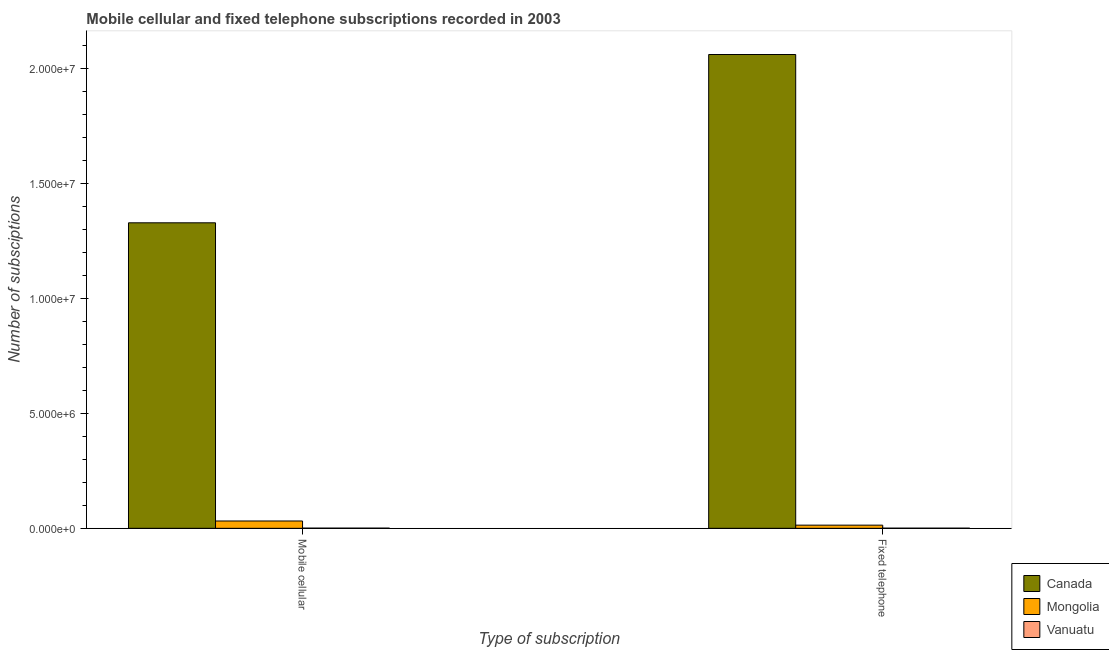Are the number of bars per tick equal to the number of legend labels?
Keep it short and to the point. Yes. How many bars are there on the 2nd tick from the left?
Make the answer very short. 3. How many bars are there on the 1st tick from the right?
Ensure brevity in your answer.  3. What is the label of the 2nd group of bars from the left?
Your answer should be very brief. Fixed telephone. What is the number of fixed telephone subscriptions in Mongolia?
Make the answer very short. 1.38e+05. Across all countries, what is the maximum number of fixed telephone subscriptions?
Provide a succinct answer. 2.06e+07. Across all countries, what is the minimum number of mobile cellular subscriptions?
Ensure brevity in your answer.  7800. In which country was the number of fixed telephone subscriptions minimum?
Provide a short and direct response. Vanuatu. What is the total number of fixed telephone subscriptions in the graph?
Your response must be concise. 2.08e+07. What is the difference between the number of fixed telephone subscriptions in Vanuatu and that in Mongolia?
Your answer should be compact. -1.32e+05. What is the difference between the number of mobile cellular subscriptions in Canada and the number of fixed telephone subscriptions in Mongolia?
Provide a short and direct response. 1.32e+07. What is the average number of mobile cellular subscriptions per country?
Your answer should be compact. 4.54e+06. What is the difference between the number of mobile cellular subscriptions and number of fixed telephone subscriptions in Mongolia?
Offer a terse response. 1.81e+05. In how many countries, is the number of fixed telephone subscriptions greater than 10000000 ?
Provide a succinct answer. 1. What is the ratio of the number of fixed telephone subscriptions in Canada to that in Mongolia?
Give a very brief answer. 149.21. Is the number of mobile cellular subscriptions in Canada less than that in Mongolia?
Your response must be concise. No. What does the 1st bar from the right in Mobile cellular represents?
Your response must be concise. Vanuatu. How many bars are there?
Keep it short and to the point. 6. How many countries are there in the graph?
Give a very brief answer. 3. What is the difference between two consecutive major ticks on the Y-axis?
Your answer should be compact. 5.00e+06. Are the values on the major ticks of Y-axis written in scientific E-notation?
Give a very brief answer. Yes. How many legend labels are there?
Keep it short and to the point. 3. How are the legend labels stacked?
Make the answer very short. Vertical. What is the title of the graph?
Give a very brief answer. Mobile cellular and fixed telephone subscriptions recorded in 2003. Does "Portugal" appear as one of the legend labels in the graph?
Offer a very short reply. No. What is the label or title of the X-axis?
Your answer should be very brief. Type of subscription. What is the label or title of the Y-axis?
Offer a terse response. Number of subsciptions. What is the Number of subsciptions of Canada in Mobile cellular?
Ensure brevity in your answer.  1.33e+07. What is the Number of subsciptions in Mongolia in Mobile cellular?
Offer a terse response. 3.19e+05. What is the Number of subsciptions of Vanuatu in Mobile cellular?
Your answer should be compact. 7800. What is the Number of subsciptions of Canada in Fixed telephone?
Your answer should be very brief. 2.06e+07. What is the Number of subsciptions of Mongolia in Fixed telephone?
Ensure brevity in your answer.  1.38e+05. What is the Number of subsciptions of Vanuatu in Fixed telephone?
Offer a very short reply. 6540. Across all Type of subscription, what is the maximum Number of subsciptions of Canada?
Offer a terse response. 2.06e+07. Across all Type of subscription, what is the maximum Number of subsciptions in Mongolia?
Ensure brevity in your answer.  3.19e+05. Across all Type of subscription, what is the maximum Number of subsciptions of Vanuatu?
Give a very brief answer. 7800. Across all Type of subscription, what is the minimum Number of subsciptions of Canada?
Offer a very short reply. 1.33e+07. Across all Type of subscription, what is the minimum Number of subsciptions of Mongolia?
Your response must be concise. 1.38e+05. Across all Type of subscription, what is the minimum Number of subsciptions of Vanuatu?
Provide a succinct answer. 6540. What is the total Number of subsciptions of Canada in the graph?
Ensure brevity in your answer.  3.39e+07. What is the total Number of subsciptions of Mongolia in the graph?
Your response must be concise. 4.57e+05. What is the total Number of subsciptions in Vanuatu in the graph?
Make the answer very short. 1.43e+04. What is the difference between the Number of subsciptions of Canada in Mobile cellular and that in Fixed telephone?
Your response must be concise. -7.32e+06. What is the difference between the Number of subsciptions of Mongolia in Mobile cellular and that in Fixed telephone?
Keep it short and to the point. 1.81e+05. What is the difference between the Number of subsciptions in Vanuatu in Mobile cellular and that in Fixed telephone?
Give a very brief answer. 1260. What is the difference between the Number of subsciptions of Canada in Mobile cellular and the Number of subsciptions of Mongolia in Fixed telephone?
Give a very brief answer. 1.32e+07. What is the difference between the Number of subsciptions of Canada in Mobile cellular and the Number of subsciptions of Vanuatu in Fixed telephone?
Give a very brief answer. 1.33e+07. What is the difference between the Number of subsciptions of Mongolia in Mobile cellular and the Number of subsciptions of Vanuatu in Fixed telephone?
Offer a terse response. 3.12e+05. What is the average Number of subsciptions of Canada per Type of subscription?
Your response must be concise. 1.70e+07. What is the average Number of subsciptions of Mongolia per Type of subscription?
Make the answer very short. 2.29e+05. What is the average Number of subsciptions in Vanuatu per Type of subscription?
Offer a very short reply. 7170. What is the difference between the Number of subsciptions in Canada and Number of subsciptions in Mongolia in Mobile cellular?
Make the answer very short. 1.30e+07. What is the difference between the Number of subsciptions in Canada and Number of subsciptions in Vanuatu in Mobile cellular?
Provide a succinct answer. 1.33e+07. What is the difference between the Number of subsciptions in Mongolia and Number of subsciptions in Vanuatu in Mobile cellular?
Make the answer very short. 3.11e+05. What is the difference between the Number of subsciptions of Canada and Number of subsciptions of Mongolia in Fixed telephone?
Offer a terse response. 2.05e+07. What is the difference between the Number of subsciptions of Canada and Number of subsciptions of Vanuatu in Fixed telephone?
Offer a terse response. 2.06e+07. What is the difference between the Number of subsciptions in Mongolia and Number of subsciptions in Vanuatu in Fixed telephone?
Keep it short and to the point. 1.32e+05. What is the ratio of the Number of subsciptions in Canada in Mobile cellular to that in Fixed telephone?
Offer a very short reply. 0.64. What is the ratio of the Number of subsciptions of Mongolia in Mobile cellular to that in Fixed telephone?
Make the answer very short. 2.31. What is the ratio of the Number of subsciptions in Vanuatu in Mobile cellular to that in Fixed telephone?
Your response must be concise. 1.19. What is the difference between the highest and the second highest Number of subsciptions in Canada?
Give a very brief answer. 7.32e+06. What is the difference between the highest and the second highest Number of subsciptions in Mongolia?
Offer a very short reply. 1.81e+05. What is the difference between the highest and the second highest Number of subsciptions of Vanuatu?
Offer a terse response. 1260. What is the difference between the highest and the lowest Number of subsciptions in Canada?
Offer a very short reply. 7.32e+06. What is the difference between the highest and the lowest Number of subsciptions of Mongolia?
Your answer should be compact. 1.81e+05. What is the difference between the highest and the lowest Number of subsciptions in Vanuatu?
Give a very brief answer. 1260. 